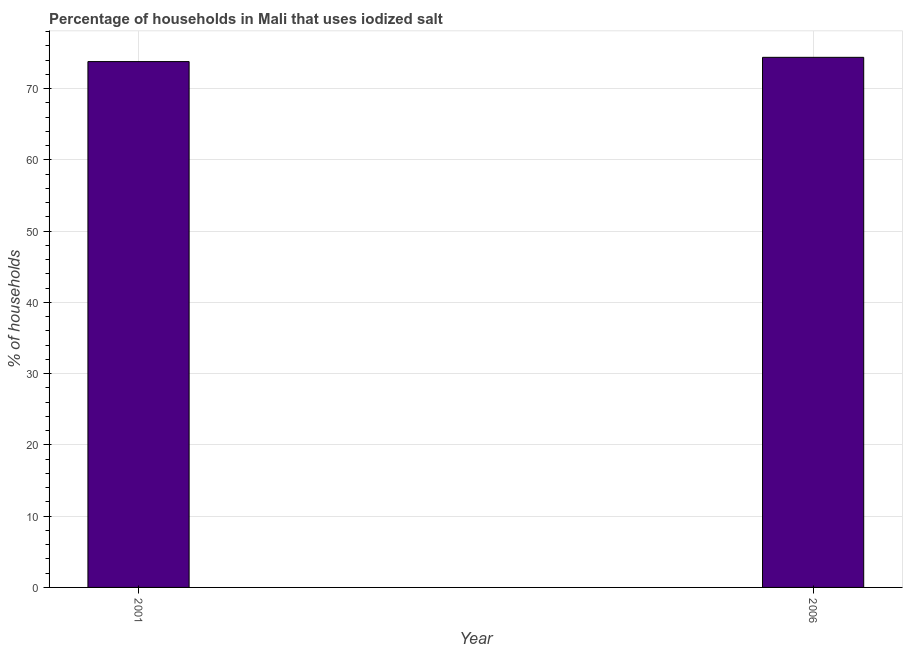What is the title of the graph?
Make the answer very short. Percentage of households in Mali that uses iodized salt. What is the label or title of the Y-axis?
Provide a succinct answer. % of households. What is the percentage of households where iodized salt is consumed in 2006?
Offer a very short reply. 74.4. Across all years, what is the maximum percentage of households where iodized salt is consumed?
Offer a very short reply. 74.4. Across all years, what is the minimum percentage of households where iodized salt is consumed?
Offer a very short reply. 73.8. What is the sum of the percentage of households where iodized salt is consumed?
Offer a terse response. 148.2. What is the difference between the percentage of households where iodized salt is consumed in 2001 and 2006?
Offer a terse response. -0.6. What is the average percentage of households where iodized salt is consumed per year?
Keep it short and to the point. 74.1. What is the median percentage of households where iodized salt is consumed?
Your answer should be compact. 74.1. In how many years, is the percentage of households where iodized salt is consumed greater than 36 %?
Provide a succinct answer. 2. Do a majority of the years between 2001 and 2006 (inclusive) have percentage of households where iodized salt is consumed greater than 66 %?
Make the answer very short. Yes. What is the ratio of the percentage of households where iodized salt is consumed in 2001 to that in 2006?
Your response must be concise. 0.99. In how many years, is the percentage of households where iodized salt is consumed greater than the average percentage of households where iodized salt is consumed taken over all years?
Your answer should be very brief. 1. How many bars are there?
Offer a very short reply. 2. How many years are there in the graph?
Offer a terse response. 2. What is the difference between two consecutive major ticks on the Y-axis?
Ensure brevity in your answer.  10. What is the % of households in 2001?
Provide a succinct answer. 73.8. What is the % of households of 2006?
Your response must be concise. 74.4. What is the difference between the % of households in 2001 and 2006?
Provide a succinct answer. -0.6. 